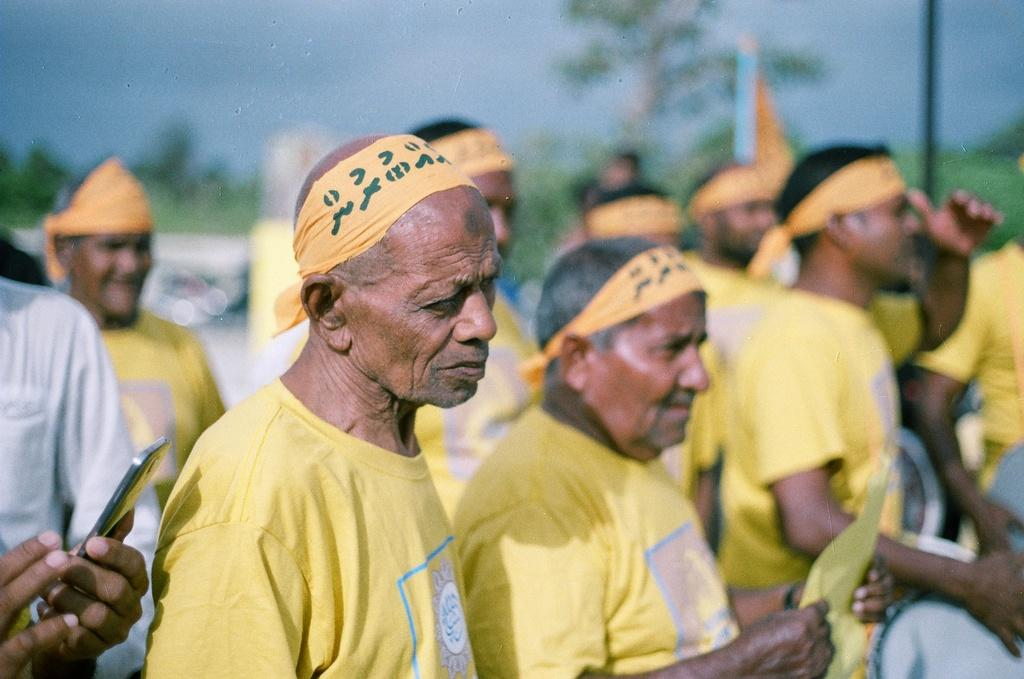How many people are in the image? There are people in the image, but the exact number is not specified. What are some people holding in the image? Some people are holding objects in the image. What type of natural elements can be seen in the image? Trees and plants are visible in the image. What is the tall, vertical object in the image? There is a pole in the image. What is attached to the pole in the image? There is a flag attached to the pole in the image. What is visible in the background of the image? The sky is visible in the background of the image. Can you tell me how many beans are in the image? There are no beans present in the image. Is there a lake visible in the image? There is no lake visible in the image. 